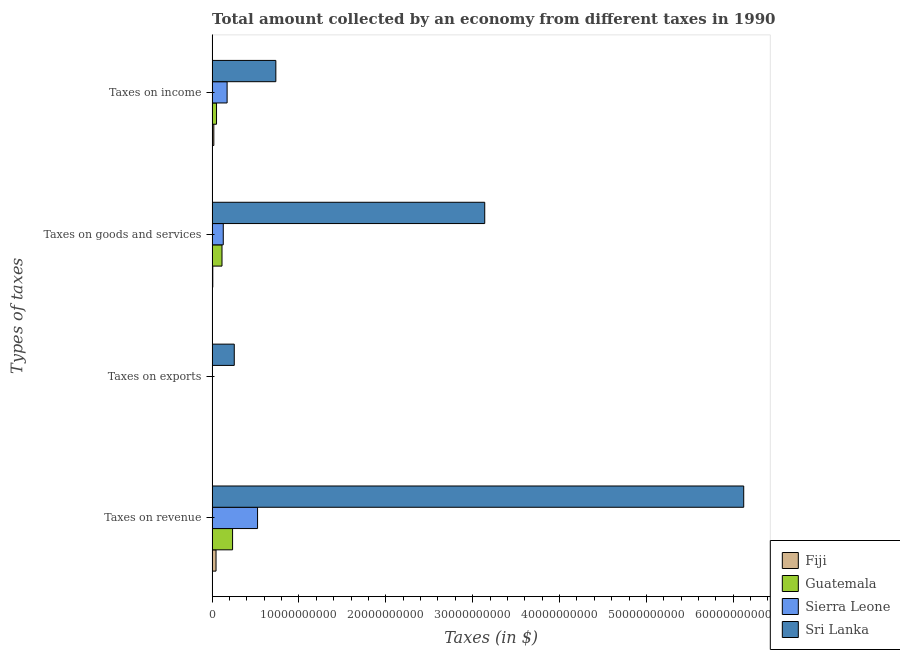Are the number of bars on each tick of the Y-axis equal?
Give a very brief answer. Yes. How many bars are there on the 3rd tick from the top?
Make the answer very short. 4. How many bars are there on the 4th tick from the bottom?
Provide a short and direct response. 4. What is the label of the 1st group of bars from the top?
Make the answer very short. Taxes on income. What is the amount collected as tax on revenue in Fiji?
Make the answer very short. 4.51e+08. Across all countries, what is the maximum amount collected as tax on revenue?
Offer a very short reply. 6.12e+1. Across all countries, what is the minimum amount collected as tax on revenue?
Provide a succinct answer. 4.51e+08. In which country was the amount collected as tax on income maximum?
Make the answer very short. Sri Lanka. In which country was the amount collected as tax on exports minimum?
Offer a terse response. Guatemala. What is the total amount collected as tax on goods in the graph?
Your response must be concise. 3.39e+1. What is the difference between the amount collected as tax on income in Fiji and that in Sri Lanka?
Offer a terse response. -7.14e+09. What is the difference between the amount collected as tax on income in Guatemala and the amount collected as tax on goods in Sri Lanka?
Your response must be concise. -3.09e+1. What is the average amount collected as tax on goods per country?
Offer a very short reply. 8.47e+09. What is the difference between the amount collected as tax on goods and amount collected as tax on income in Sri Lanka?
Keep it short and to the point. 2.41e+1. In how many countries, is the amount collected as tax on goods greater than 36000000000 $?
Offer a very short reply. 0. What is the ratio of the amount collected as tax on goods in Guatemala to that in Sierra Leone?
Your response must be concise. 0.89. What is the difference between the highest and the second highest amount collected as tax on income?
Provide a short and direct response. 5.61e+09. What is the difference between the highest and the lowest amount collected as tax on revenue?
Offer a terse response. 6.08e+1. In how many countries, is the amount collected as tax on revenue greater than the average amount collected as tax on revenue taken over all countries?
Your answer should be compact. 1. What does the 1st bar from the top in Taxes on revenue represents?
Give a very brief answer. Sri Lanka. What does the 3rd bar from the bottom in Taxes on exports represents?
Your response must be concise. Sierra Leone. Is it the case that in every country, the sum of the amount collected as tax on revenue and amount collected as tax on exports is greater than the amount collected as tax on goods?
Ensure brevity in your answer.  Yes. How many bars are there?
Make the answer very short. 16. How many countries are there in the graph?
Provide a short and direct response. 4. What is the difference between two consecutive major ticks on the X-axis?
Your answer should be very brief. 1.00e+1. How are the legend labels stacked?
Give a very brief answer. Vertical. What is the title of the graph?
Give a very brief answer. Total amount collected by an economy from different taxes in 1990. Does "Moldova" appear as one of the legend labels in the graph?
Your answer should be compact. No. What is the label or title of the X-axis?
Your response must be concise. Taxes (in $). What is the label or title of the Y-axis?
Offer a very short reply. Types of taxes. What is the Taxes (in $) in Fiji in Taxes on revenue?
Ensure brevity in your answer.  4.51e+08. What is the Taxes (in $) in Guatemala in Taxes on revenue?
Provide a succinct answer. 2.36e+09. What is the Taxes (in $) of Sierra Leone in Taxes on revenue?
Your response must be concise. 5.23e+09. What is the Taxes (in $) of Sri Lanka in Taxes on revenue?
Ensure brevity in your answer.  6.12e+1. What is the Taxes (in $) of Fiji in Taxes on exports?
Offer a very short reply. 1.50e+07. What is the Taxes (in $) in Guatemala in Taxes on exports?
Provide a succinct answer. 4.63e+06. What is the Taxes (in $) of Sierra Leone in Taxes on exports?
Provide a succinct answer. 2.27e+07. What is the Taxes (in $) in Sri Lanka in Taxes on exports?
Your answer should be compact. 2.55e+09. What is the Taxes (in $) of Fiji in Taxes on goods and services?
Provide a short and direct response. 7.76e+07. What is the Taxes (in $) of Guatemala in Taxes on goods and services?
Offer a very short reply. 1.14e+09. What is the Taxes (in $) of Sierra Leone in Taxes on goods and services?
Provide a succinct answer. 1.28e+09. What is the Taxes (in $) in Sri Lanka in Taxes on goods and services?
Offer a terse response. 3.14e+1. What is the Taxes (in $) of Fiji in Taxes on income?
Ensure brevity in your answer.  1.97e+08. What is the Taxes (in $) in Guatemala in Taxes on income?
Your response must be concise. 5.07e+08. What is the Taxes (in $) in Sierra Leone in Taxes on income?
Your answer should be very brief. 1.72e+09. What is the Taxes (in $) of Sri Lanka in Taxes on income?
Provide a succinct answer. 7.34e+09. Across all Types of taxes, what is the maximum Taxes (in $) in Fiji?
Provide a short and direct response. 4.51e+08. Across all Types of taxes, what is the maximum Taxes (in $) of Guatemala?
Give a very brief answer. 2.36e+09. Across all Types of taxes, what is the maximum Taxes (in $) of Sierra Leone?
Ensure brevity in your answer.  5.23e+09. Across all Types of taxes, what is the maximum Taxes (in $) of Sri Lanka?
Ensure brevity in your answer.  6.12e+1. Across all Types of taxes, what is the minimum Taxes (in $) of Fiji?
Give a very brief answer. 1.50e+07. Across all Types of taxes, what is the minimum Taxes (in $) of Guatemala?
Your answer should be very brief. 4.63e+06. Across all Types of taxes, what is the minimum Taxes (in $) of Sierra Leone?
Provide a short and direct response. 2.27e+07. Across all Types of taxes, what is the minimum Taxes (in $) of Sri Lanka?
Keep it short and to the point. 2.55e+09. What is the total Taxes (in $) in Fiji in the graph?
Your response must be concise. 7.40e+08. What is the total Taxes (in $) in Guatemala in the graph?
Your answer should be very brief. 4.00e+09. What is the total Taxes (in $) of Sierra Leone in the graph?
Make the answer very short. 8.26e+09. What is the total Taxes (in $) of Sri Lanka in the graph?
Ensure brevity in your answer.  1.02e+11. What is the difference between the Taxes (in $) of Fiji in Taxes on revenue and that in Taxes on exports?
Keep it short and to the point. 4.36e+08. What is the difference between the Taxes (in $) in Guatemala in Taxes on revenue and that in Taxes on exports?
Provide a succinct answer. 2.35e+09. What is the difference between the Taxes (in $) of Sierra Leone in Taxes on revenue and that in Taxes on exports?
Make the answer very short. 5.21e+09. What is the difference between the Taxes (in $) of Sri Lanka in Taxes on revenue and that in Taxes on exports?
Provide a succinct answer. 5.87e+1. What is the difference between the Taxes (in $) in Fiji in Taxes on revenue and that in Taxes on goods and services?
Provide a short and direct response. 3.73e+08. What is the difference between the Taxes (in $) of Guatemala in Taxes on revenue and that in Taxes on goods and services?
Ensure brevity in your answer.  1.22e+09. What is the difference between the Taxes (in $) in Sierra Leone in Taxes on revenue and that in Taxes on goods and services?
Your response must be concise. 3.95e+09. What is the difference between the Taxes (in $) in Sri Lanka in Taxes on revenue and that in Taxes on goods and services?
Make the answer very short. 2.98e+1. What is the difference between the Taxes (in $) of Fiji in Taxes on revenue and that in Taxes on income?
Your answer should be very brief. 2.53e+08. What is the difference between the Taxes (in $) of Guatemala in Taxes on revenue and that in Taxes on income?
Your answer should be compact. 1.85e+09. What is the difference between the Taxes (in $) in Sierra Leone in Taxes on revenue and that in Taxes on income?
Your response must be concise. 3.51e+09. What is the difference between the Taxes (in $) in Sri Lanka in Taxes on revenue and that in Taxes on income?
Keep it short and to the point. 5.39e+1. What is the difference between the Taxes (in $) of Fiji in Taxes on exports and that in Taxes on goods and services?
Keep it short and to the point. -6.26e+07. What is the difference between the Taxes (in $) in Guatemala in Taxes on exports and that in Taxes on goods and services?
Your answer should be compact. -1.13e+09. What is the difference between the Taxes (in $) of Sierra Leone in Taxes on exports and that in Taxes on goods and services?
Your response must be concise. -1.26e+09. What is the difference between the Taxes (in $) of Sri Lanka in Taxes on exports and that in Taxes on goods and services?
Make the answer very short. -2.88e+1. What is the difference between the Taxes (in $) in Fiji in Taxes on exports and that in Taxes on income?
Your response must be concise. -1.82e+08. What is the difference between the Taxes (in $) of Guatemala in Taxes on exports and that in Taxes on income?
Give a very brief answer. -5.02e+08. What is the difference between the Taxes (in $) of Sierra Leone in Taxes on exports and that in Taxes on income?
Your answer should be very brief. -1.70e+09. What is the difference between the Taxes (in $) in Sri Lanka in Taxes on exports and that in Taxes on income?
Keep it short and to the point. -4.79e+09. What is the difference between the Taxes (in $) of Fiji in Taxes on goods and services and that in Taxes on income?
Provide a short and direct response. -1.20e+08. What is the difference between the Taxes (in $) in Guatemala in Taxes on goods and services and that in Taxes on income?
Keep it short and to the point. 6.30e+08. What is the difference between the Taxes (in $) of Sierra Leone in Taxes on goods and services and that in Taxes on income?
Your response must be concise. -4.42e+08. What is the difference between the Taxes (in $) in Sri Lanka in Taxes on goods and services and that in Taxes on income?
Provide a succinct answer. 2.41e+1. What is the difference between the Taxes (in $) of Fiji in Taxes on revenue and the Taxes (in $) of Guatemala in Taxes on exports?
Your answer should be compact. 4.46e+08. What is the difference between the Taxes (in $) in Fiji in Taxes on revenue and the Taxes (in $) in Sierra Leone in Taxes on exports?
Your response must be concise. 4.28e+08. What is the difference between the Taxes (in $) in Fiji in Taxes on revenue and the Taxes (in $) in Sri Lanka in Taxes on exports?
Your answer should be compact. -2.10e+09. What is the difference between the Taxes (in $) in Guatemala in Taxes on revenue and the Taxes (in $) in Sierra Leone in Taxes on exports?
Your response must be concise. 2.33e+09. What is the difference between the Taxes (in $) of Guatemala in Taxes on revenue and the Taxes (in $) of Sri Lanka in Taxes on exports?
Provide a short and direct response. -1.93e+08. What is the difference between the Taxes (in $) in Sierra Leone in Taxes on revenue and the Taxes (in $) in Sri Lanka in Taxes on exports?
Your response must be concise. 2.68e+09. What is the difference between the Taxes (in $) of Fiji in Taxes on revenue and the Taxes (in $) of Guatemala in Taxes on goods and services?
Offer a very short reply. -6.86e+08. What is the difference between the Taxes (in $) in Fiji in Taxes on revenue and the Taxes (in $) in Sierra Leone in Taxes on goods and services?
Keep it short and to the point. -8.33e+08. What is the difference between the Taxes (in $) of Fiji in Taxes on revenue and the Taxes (in $) of Sri Lanka in Taxes on goods and services?
Keep it short and to the point. -3.09e+1. What is the difference between the Taxes (in $) in Guatemala in Taxes on revenue and the Taxes (in $) in Sierra Leone in Taxes on goods and services?
Provide a succinct answer. 1.07e+09. What is the difference between the Taxes (in $) of Guatemala in Taxes on revenue and the Taxes (in $) of Sri Lanka in Taxes on goods and services?
Keep it short and to the point. -2.90e+1. What is the difference between the Taxes (in $) of Sierra Leone in Taxes on revenue and the Taxes (in $) of Sri Lanka in Taxes on goods and services?
Offer a very short reply. -2.62e+1. What is the difference between the Taxes (in $) in Fiji in Taxes on revenue and the Taxes (in $) in Guatemala in Taxes on income?
Give a very brief answer. -5.64e+07. What is the difference between the Taxes (in $) of Fiji in Taxes on revenue and the Taxes (in $) of Sierra Leone in Taxes on income?
Your answer should be compact. -1.27e+09. What is the difference between the Taxes (in $) of Fiji in Taxes on revenue and the Taxes (in $) of Sri Lanka in Taxes on income?
Offer a terse response. -6.89e+09. What is the difference between the Taxes (in $) in Guatemala in Taxes on revenue and the Taxes (in $) in Sierra Leone in Taxes on income?
Provide a succinct answer. 6.31e+08. What is the difference between the Taxes (in $) in Guatemala in Taxes on revenue and the Taxes (in $) in Sri Lanka in Taxes on income?
Provide a short and direct response. -4.98e+09. What is the difference between the Taxes (in $) in Sierra Leone in Taxes on revenue and the Taxes (in $) in Sri Lanka in Taxes on income?
Offer a terse response. -2.11e+09. What is the difference between the Taxes (in $) in Fiji in Taxes on exports and the Taxes (in $) in Guatemala in Taxes on goods and services?
Provide a succinct answer. -1.12e+09. What is the difference between the Taxes (in $) of Fiji in Taxes on exports and the Taxes (in $) of Sierra Leone in Taxes on goods and services?
Provide a short and direct response. -1.27e+09. What is the difference between the Taxes (in $) in Fiji in Taxes on exports and the Taxes (in $) in Sri Lanka in Taxes on goods and services?
Your answer should be very brief. -3.14e+1. What is the difference between the Taxes (in $) in Guatemala in Taxes on exports and the Taxes (in $) in Sierra Leone in Taxes on goods and services?
Keep it short and to the point. -1.28e+09. What is the difference between the Taxes (in $) of Guatemala in Taxes on exports and the Taxes (in $) of Sri Lanka in Taxes on goods and services?
Ensure brevity in your answer.  -3.14e+1. What is the difference between the Taxes (in $) in Sierra Leone in Taxes on exports and the Taxes (in $) in Sri Lanka in Taxes on goods and services?
Your answer should be very brief. -3.14e+1. What is the difference between the Taxes (in $) in Fiji in Taxes on exports and the Taxes (in $) in Guatemala in Taxes on income?
Your answer should be compact. -4.92e+08. What is the difference between the Taxes (in $) in Fiji in Taxes on exports and the Taxes (in $) in Sierra Leone in Taxes on income?
Keep it short and to the point. -1.71e+09. What is the difference between the Taxes (in $) of Fiji in Taxes on exports and the Taxes (in $) of Sri Lanka in Taxes on income?
Offer a very short reply. -7.32e+09. What is the difference between the Taxes (in $) in Guatemala in Taxes on exports and the Taxes (in $) in Sierra Leone in Taxes on income?
Offer a terse response. -1.72e+09. What is the difference between the Taxes (in $) in Guatemala in Taxes on exports and the Taxes (in $) in Sri Lanka in Taxes on income?
Your answer should be compact. -7.33e+09. What is the difference between the Taxes (in $) in Sierra Leone in Taxes on exports and the Taxes (in $) in Sri Lanka in Taxes on income?
Your answer should be very brief. -7.31e+09. What is the difference between the Taxes (in $) in Fiji in Taxes on goods and services and the Taxes (in $) in Guatemala in Taxes on income?
Your answer should be very brief. -4.29e+08. What is the difference between the Taxes (in $) in Fiji in Taxes on goods and services and the Taxes (in $) in Sierra Leone in Taxes on income?
Your answer should be very brief. -1.65e+09. What is the difference between the Taxes (in $) of Fiji in Taxes on goods and services and the Taxes (in $) of Sri Lanka in Taxes on income?
Keep it short and to the point. -7.26e+09. What is the difference between the Taxes (in $) of Guatemala in Taxes on goods and services and the Taxes (in $) of Sierra Leone in Taxes on income?
Make the answer very short. -5.88e+08. What is the difference between the Taxes (in $) in Guatemala in Taxes on goods and services and the Taxes (in $) in Sri Lanka in Taxes on income?
Provide a short and direct response. -6.20e+09. What is the difference between the Taxes (in $) in Sierra Leone in Taxes on goods and services and the Taxes (in $) in Sri Lanka in Taxes on income?
Keep it short and to the point. -6.05e+09. What is the average Taxes (in $) of Fiji per Types of taxes?
Your answer should be compact. 1.85e+08. What is the average Taxes (in $) in Guatemala per Types of taxes?
Your response must be concise. 1.00e+09. What is the average Taxes (in $) in Sierra Leone per Types of taxes?
Ensure brevity in your answer.  2.07e+09. What is the average Taxes (in $) in Sri Lanka per Types of taxes?
Give a very brief answer. 2.56e+1. What is the difference between the Taxes (in $) in Fiji and Taxes (in $) in Guatemala in Taxes on revenue?
Make the answer very short. -1.91e+09. What is the difference between the Taxes (in $) in Fiji and Taxes (in $) in Sierra Leone in Taxes on revenue?
Your answer should be compact. -4.78e+09. What is the difference between the Taxes (in $) of Fiji and Taxes (in $) of Sri Lanka in Taxes on revenue?
Ensure brevity in your answer.  -6.08e+1. What is the difference between the Taxes (in $) in Guatemala and Taxes (in $) in Sierra Leone in Taxes on revenue?
Your answer should be compact. -2.88e+09. What is the difference between the Taxes (in $) in Guatemala and Taxes (in $) in Sri Lanka in Taxes on revenue?
Give a very brief answer. -5.89e+1. What is the difference between the Taxes (in $) of Sierra Leone and Taxes (in $) of Sri Lanka in Taxes on revenue?
Your response must be concise. -5.60e+1. What is the difference between the Taxes (in $) in Fiji and Taxes (in $) in Guatemala in Taxes on exports?
Provide a short and direct response. 1.03e+07. What is the difference between the Taxes (in $) of Fiji and Taxes (in $) of Sierra Leone in Taxes on exports?
Provide a short and direct response. -7.74e+06. What is the difference between the Taxes (in $) in Fiji and Taxes (in $) in Sri Lanka in Taxes on exports?
Give a very brief answer. -2.53e+09. What is the difference between the Taxes (in $) of Guatemala and Taxes (in $) of Sierra Leone in Taxes on exports?
Offer a very short reply. -1.81e+07. What is the difference between the Taxes (in $) of Guatemala and Taxes (in $) of Sri Lanka in Taxes on exports?
Offer a very short reply. -2.54e+09. What is the difference between the Taxes (in $) of Sierra Leone and Taxes (in $) of Sri Lanka in Taxes on exports?
Your answer should be compact. -2.53e+09. What is the difference between the Taxes (in $) in Fiji and Taxes (in $) in Guatemala in Taxes on goods and services?
Provide a succinct answer. -1.06e+09. What is the difference between the Taxes (in $) in Fiji and Taxes (in $) in Sierra Leone in Taxes on goods and services?
Your answer should be compact. -1.21e+09. What is the difference between the Taxes (in $) of Fiji and Taxes (in $) of Sri Lanka in Taxes on goods and services?
Your response must be concise. -3.13e+1. What is the difference between the Taxes (in $) in Guatemala and Taxes (in $) in Sierra Leone in Taxes on goods and services?
Your answer should be compact. -1.46e+08. What is the difference between the Taxes (in $) of Guatemala and Taxes (in $) of Sri Lanka in Taxes on goods and services?
Make the answer very short. -3.03e+1. What is the difference between the Taxes (in $) of Sierra Leone and Taxes (in $) of Sri Lanka in Taxes on goods and services?
Give a very brief answer. -3.01e+1. What is the difference between the Taxes (in $) of Fiji and Taxes (in $) of Guatemala in Taxes on income?
Provide a short and direct response. -3.10e+08. What is the difference between the Taxes (in $) in Fiji and Taxes (in $) in Sierra Leone in Taxes on income?
Your answer should be very brief. -1.53e+09. What is the difference between the Taxes (in $) in Fiji and Taxes (in $) in Sri Lanka in Taxes on income?
Offer a very short reply. -7.14e+09. What is the difference between the Taxes (in $) of Guatemala and Taxes (in $) of Sierra Leone in Taxes on income?
Keep it short and to the point. -1.22e+09. What is the difference between the Taxes (in $) in Guatemala and Taxes (in $) in Sri Lanka in Taxes on income?
Your response must be concise. -6.83e+09. What is the difference between the Taxes (in $) in Sierra Leone and Taxes (in $) in Sri Lanka in Taxes on income?
Your response must be concise. -5.61e+09. What is the ratio of the Taxes (in $) of Fiji in Taxes on revenue to that in Taxes on exports?
Your response must be concise. 30.12. What is the ratio of the Taxes (in $) in Guatemala in Taxes on revenue to that in Taxes on exports?
Your answer should be very brief. 508.84. What is the ratio of the Taxes (in $) in Sierra Leone in Taxes on revenue to that in Taxes on exports?
Offer a very short reply. 230.44. What is the ratio of the Taxes (in $) in Sri Lanka in Taxes on revenue to that in Taxes on exports?
Offer a very short reply. 24.01. What is the ratio of the Taxes (in $) of Fiji in Taxes on revenue to that in Taxes on goods and services?
Your answer should be compact. 5.81. What is the ratio of the Taxes (in $) of Guatemala in Taxes on revenue to that in Taxes on goods and services?
Make the answer very short. 2.07. What is the ratio of the Taxes (in $) in Sierra Leone in Taxes on revenue to that in Taxes on goods and services?
Ensure brevity in your answer.  4.08. What is the ratio of the Taxes (in $) of Sri Lanka in Taxes on revenue to that in Taxes on goods and services?
Keep it short and to the point. 1.95. What is the ratio of the Taxes (in $) of Fiji in Taxes on revenue to that in Taxes on income?
Make the answer very short. 2.29. What is the ratio of the Taxes (in $) of Guatemala in Taxes on revenue to that in Taxes on income?
Offer a very short reply. 4.65. What is the ratio of the Taxes (in $) of Sierra Leone in Taxes on revenue to that in Taxes on income?
Your answer should be very brief. 3.03. What is the ratio of the Taxes (in $) of Sri Lanka in Taxes on revenue to that in Taxes on income?
Your response must be concise. 8.34. What is the ratio of the Taxes (in $) of Fiji in Taxes on exports to that in Taxes on goods and services?
Your response must be concise. 0.19. What is the ratio of the Taxes (in $) of Guatemala in Taxes on exports to that in Taxes on goods and services?
Your response must be concise. 0. What is the ratio of the Taxes (in $) of Sierra Leone in Taxes on exports to that in Taxes on goods and services?
Offer a very short reply. 0.02. What is the ratio of the Taxes (in $) of Sri Lanka in Taxes on exports to that in Taxes on goods and services?
Make the answer very short. 0.08. What is the ratio of the Taxes (in $) in Fiji in Taxes on exports to that in Taxes on income?
Make the answer very short. 0.08. What is the ratio of the Taxes (in $) in Guatemala in Taxes on exports to that in Taxes on income?
Offer a terse response. 0.01. What is the ratio of the Taxes (in $) in Sierra Leone in Taxes on exports to that in Taxes on income?
Ensure brevity in your answer.  0.01. What is the ratio of the Taxes (in $) in Sri Lanka in Taxes on exports to that in Taxes on income?
Provide a short and direct response. 0.35. What is the ratio of the Taxes (in $) of Fiji in Taxes on goods and services to that in Taxes on income?
Give a very brief answer. 0.39. What is the ratio of the Taxes (in $) in Guatemala in Taxes on goods and services to that in Taxes on income?
Offer a terse response. 2.24. What is the ratio of the Taxes (in $) in Sierra Leone in Taxes on goods and services to that in Taxes on income?
Your answer should be very brief. 0.74. What is the ratio of the Taxes (in $) in Sri Lanka in Taxes on goods and services to that in Taxes on income?
Your response must be concise. 4.28. What is the difference between the highest and the second highest Taxes (in $) of Fiji?
Your answer should be compact. 2.53e+08. What is the difference between the highest and the second highest Taxes (in $) in Guatemala?
Give a very brief answer. 1.22e+09. What is the difference between the highest and the second highest Taxes (in $) of Sierra Leone?
Ensure brevity in your answer.  3.51e+09. What is the difference between the highest and the second highest Taxes (in $) of Sri Lanka?
Your answer should be compact. 2.98e+1. What is the difference between the highest and the lowest Taxes (in $) in Fiji?
Your answer should be compact. 4.36e+08. What is the difference between the highest and the lowest Taxes (in $) of Guatemala?
Give a very brief answer. 2.35e+09. What is the difference between the highest and the lowest Taxes (in $) in Sierra Leone?
Your response must be concise. 5.21e+09. What is the difference between the highest and the lowest Taxes (in $) in Sri Lanka?
Offer a terse response. 5.87e+1. 